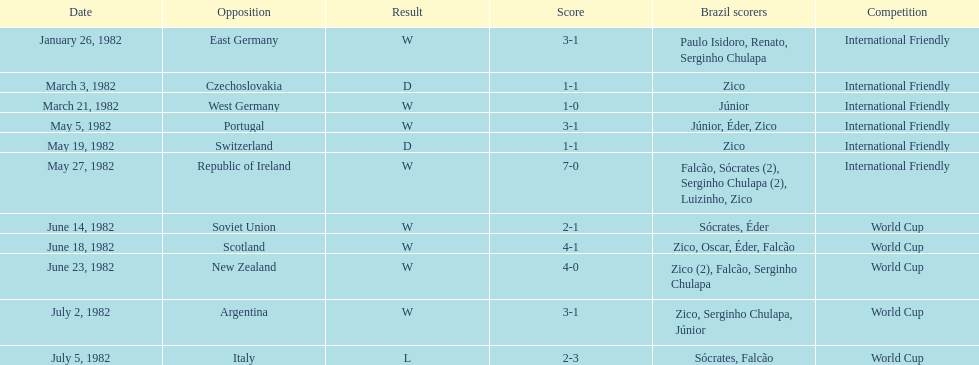How many times did brazil play west germany during the 1982 season? 1. 